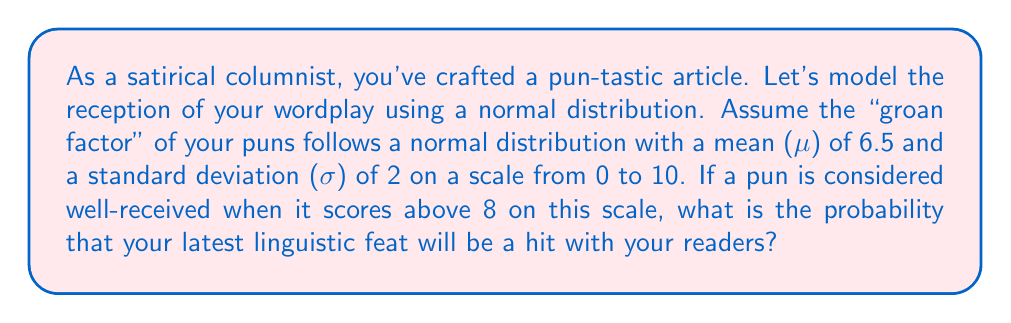Help me with this question. To solve this problem, we need to follow these steps:

1) We're dealing with a normal distribution where:
   $\mu = 6.5$ and $\sigma = 2$

2) We want to find P(X > 8), where X is the "groan factor" score.

3) First, we need to standardize our value. The z-score formula is:
   $$z = \frac{x - \mu}{\sigma}$$

4) Plugging in our values:
   $$z = \frac{8 - 6.5}{2} = \frac{1.5}{2} = 0.75$$

5) Now we need to find P(Z > 0.75) where Z is the standard normal variable.

6) Using a standard normal table or calculator, we can find that:
   P(Z < 0.75) ≈ 0.7734

7) Since we want P(Z > 0.75), we subtract this from 1:
   P(Z > 0.75) = 1 - P(Z < 0.75) = 1 - 0.7734 = 0.2266

8) Therefore, the probability of the pun being well-received (scoring above 8) is approximately 0.2266 or 22.66%.
Answer: 0.2266 